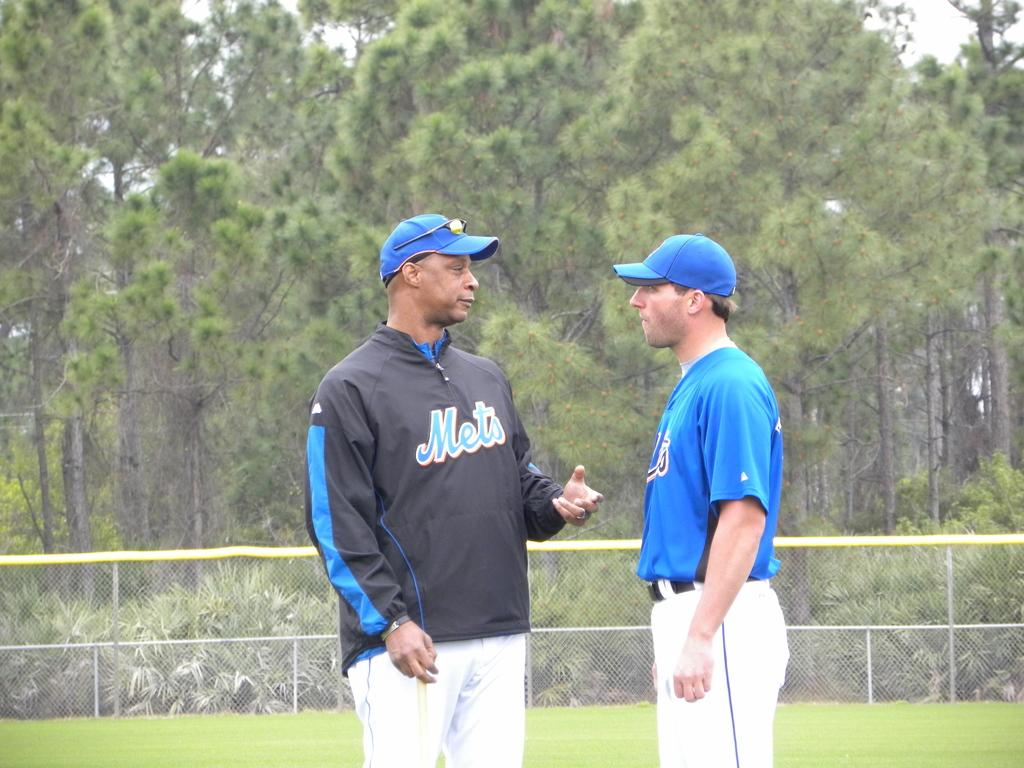Provide a one-sentence caption for the provided image. Two men in Mets clothing have a conversation on a baseball field. 